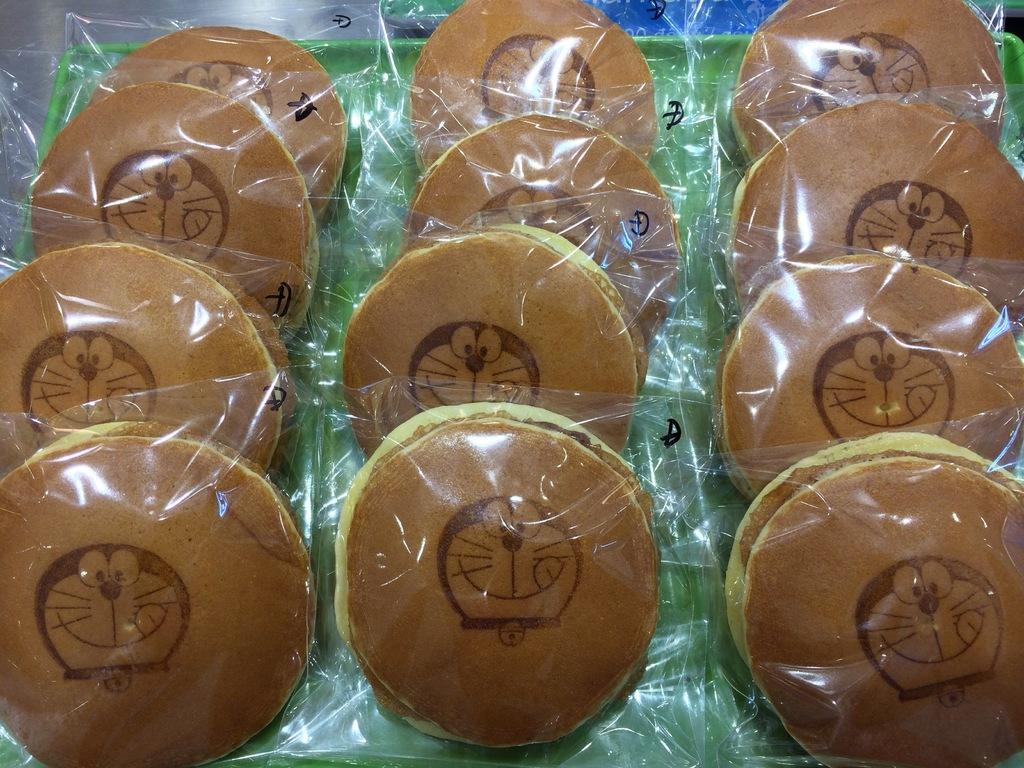What is present on the tray in the image? There is a tray in the image, and it contains pancakes. How are the pancakes packaged on the tray? The pancakes are packed in polythene covers. What type of prose can be seen on the tray in the image? There is no prose present on the tray in the image; it contains pancakes packed in polythene covers. 